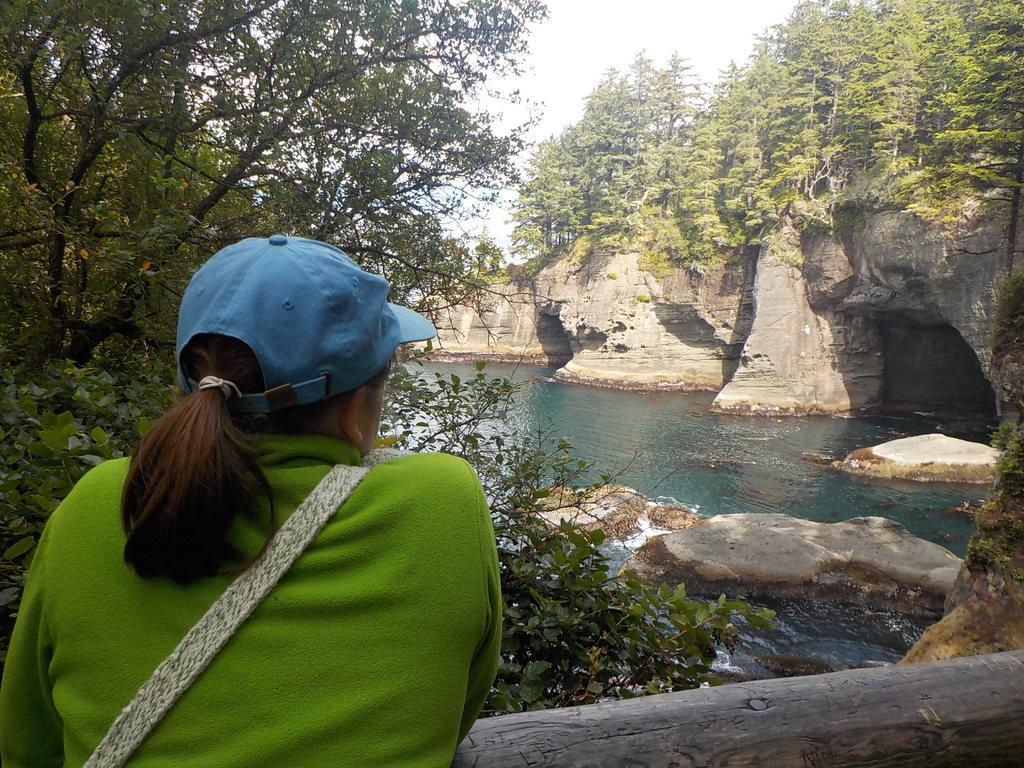What natural feature is the main subject of the image? There is a river in the image. What can be seen around the river? The river is surrounded by many trees. What is the woman in the image doing? The woman is standing in front of the river and watching the view. What is separating the woman from the river? The woman is behind a wooden fence. What type of straw is the woman holding in her hand in the image? There is no straw present in the image; the woman is simply watching the view. What is the woman's mind thinking about while she watches the view? The image does not provide information about the woman's thoughts or mental state, so we cannot determine what she is thinking. 